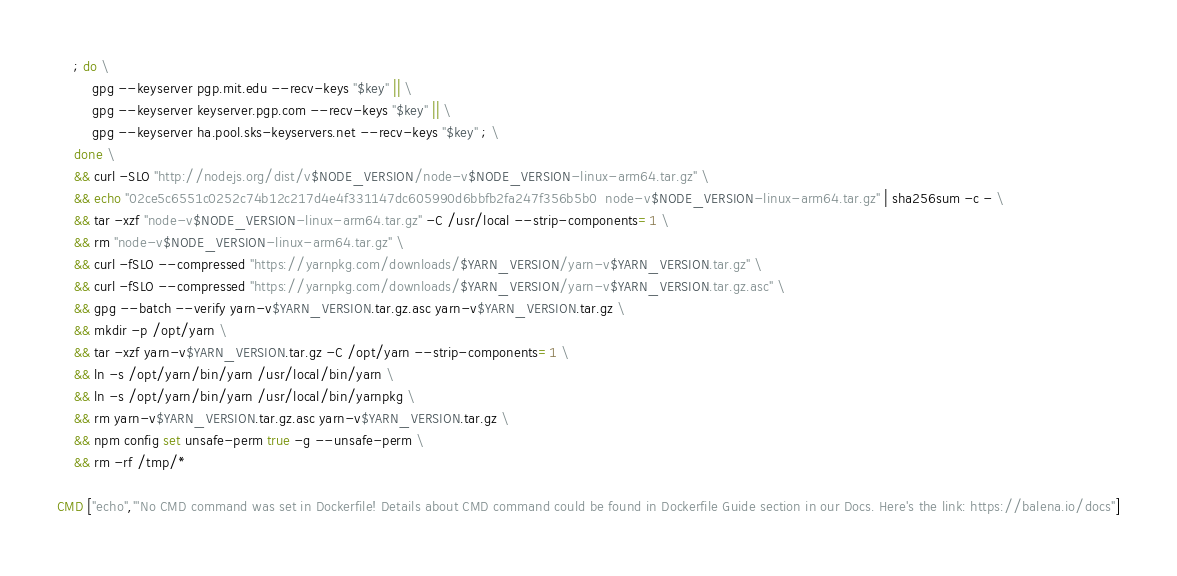Convert code to text. <code><loc_0><loc_0><loc_500><loc_500><_Dockerfile_>	; do \
		gpg --keyserver pgp.mit.edu --recv-keys "$key" || \
		gpg --keyserver keyserver.pgp.com --recv-keys "$key" || \
		gpg --keyserver ha.pool.sks-keyservers.net --recv-keys "$key" ; \
	done \
	&& curl -SLO "http://nodejs.org/dist/v$NODE_VERSION/node-v$NODE_VERSION-linux-arm64.tar.gz" \
	&& echo "02ce5c6551c0252c74b12c217d4e4f331147dc605990d6bbfb2fa247f356b5b0  node-v$NODE_VERSION-linux-arm64.tar.gz" | sha256sum -c - \
	&& tar -xzf "node-v$NODE_VERSION-linux-arm64.tar.gz" -C /usr/local --strip-components=1 \
	&& rm "node-v$NODE_VERSION-linux-arm64.tar.gz" \
	&& curl -fSLO --compressed "https://yarnpkg.com/downloads/$YARN_VERSION/yarn-v$YARN_VERSION.tar.gz" \
	&& curl -fSLO --compressed "https://yarnpkg.com/downloads/$YARN_VERSION/yarn-v$YARN_VERSION.tar.gz.asc" \
	&& gpg --batch --verify yarn-v$YARN_VERSION.tar.gz.asc yarn-v$YARN_VERSION.tar.gz \
	&& mkdir -p /opt/yarn \
	&& tar -xzf yarn-v$YARN_VERSION.tar.gz -C /opt/yarn --strip-components=1 \
	&& ln -s /opt/yarn/bin/yarn /usr/local/bin/yarn \
	&& ln -s /opt/yarn/bin/yarn /usr/local/bin/yarnpkg \
	&& rm yarn-v$YARN_VERSION.tar.gz.asc yarn-v$YARN_VERSION.tar.gz \
	&& npm config set unsafe-perm true -g --unsafe-perm \
	&& rm -rf /tmp/*

CMD ["echo","'No CMD command was set in Dockerfile! Details about CMD command could be found in Dockerfile Guide section in our Docs. Here's the link: https://balena.io/docs"]</code> 